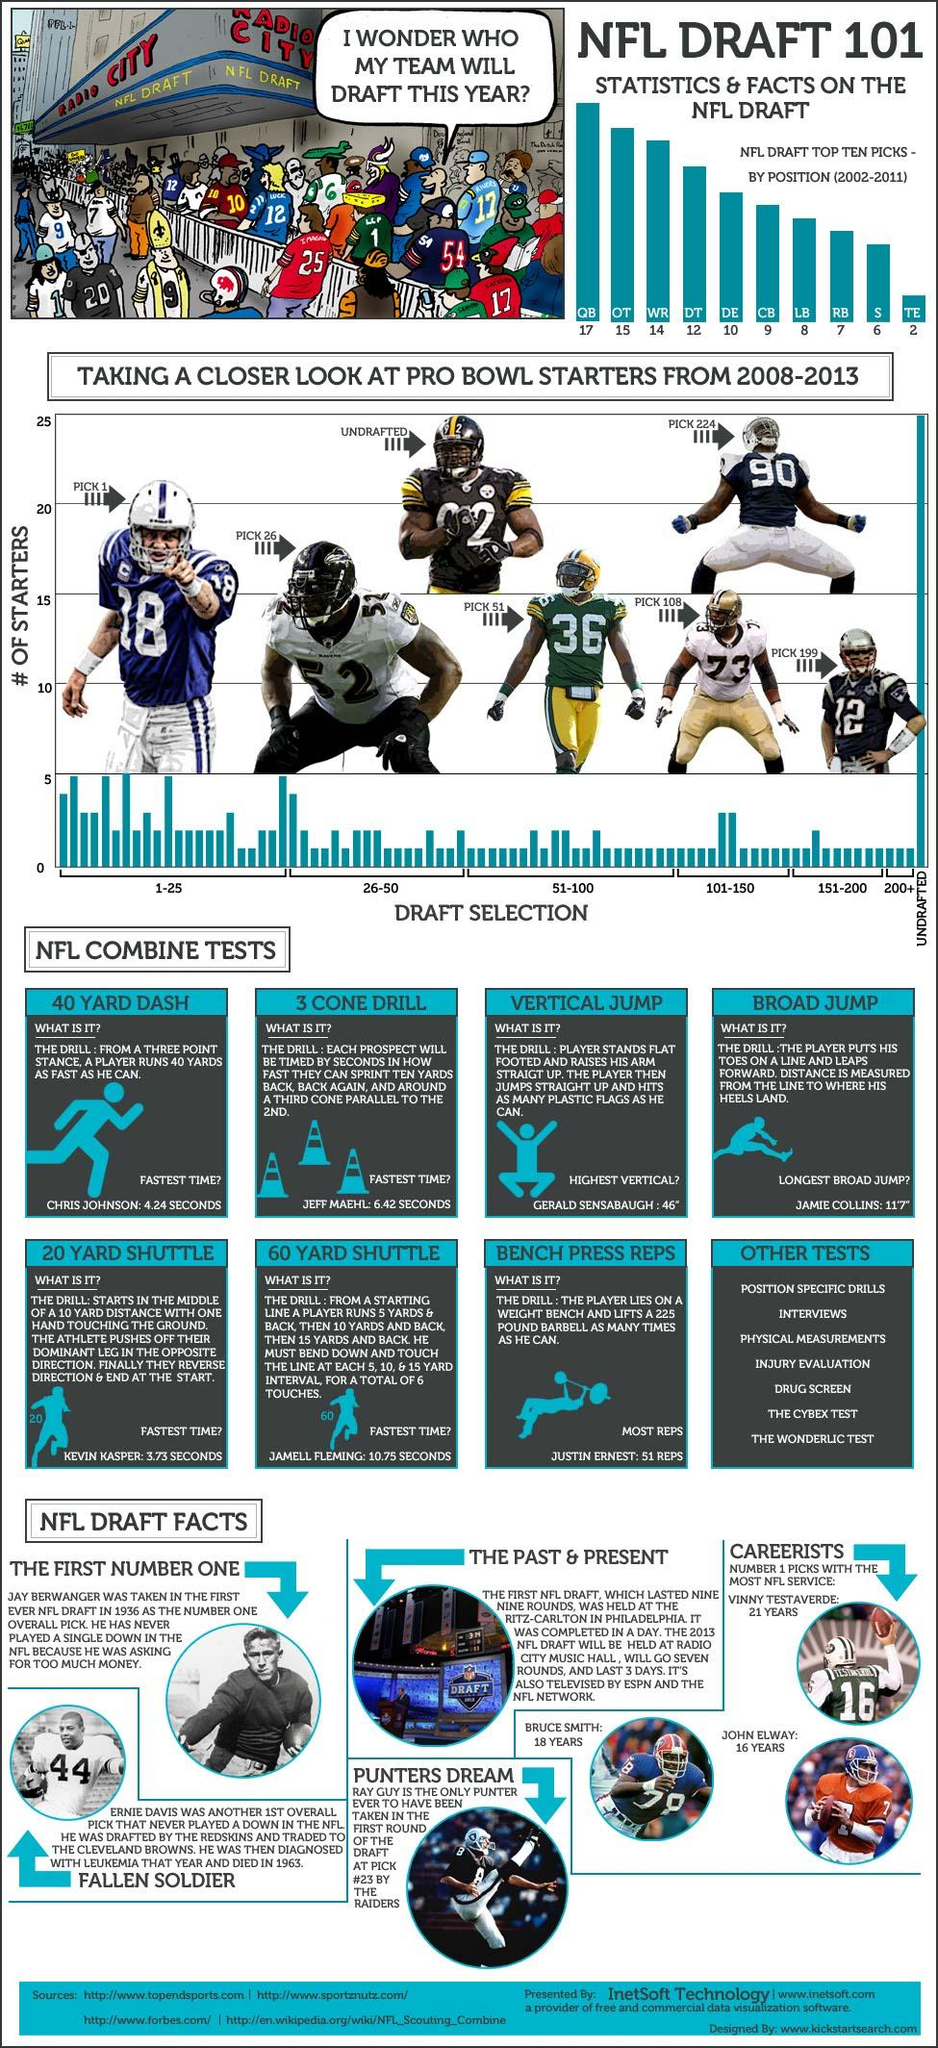Mention a couple of crucial points in this snapshot. The player with jersey number 16 is Vinny Testeraverde. The fastest recorded time for a 20-yard shuttle was 3.73 seconds. This was achieved by an individual and is the current record. The player wearing the helmet with the number 92 has been listed as undrafted. What is the player number with the jersey number 90? The pick number is 224. The player with jersey number 8 is named Ray Guy. 